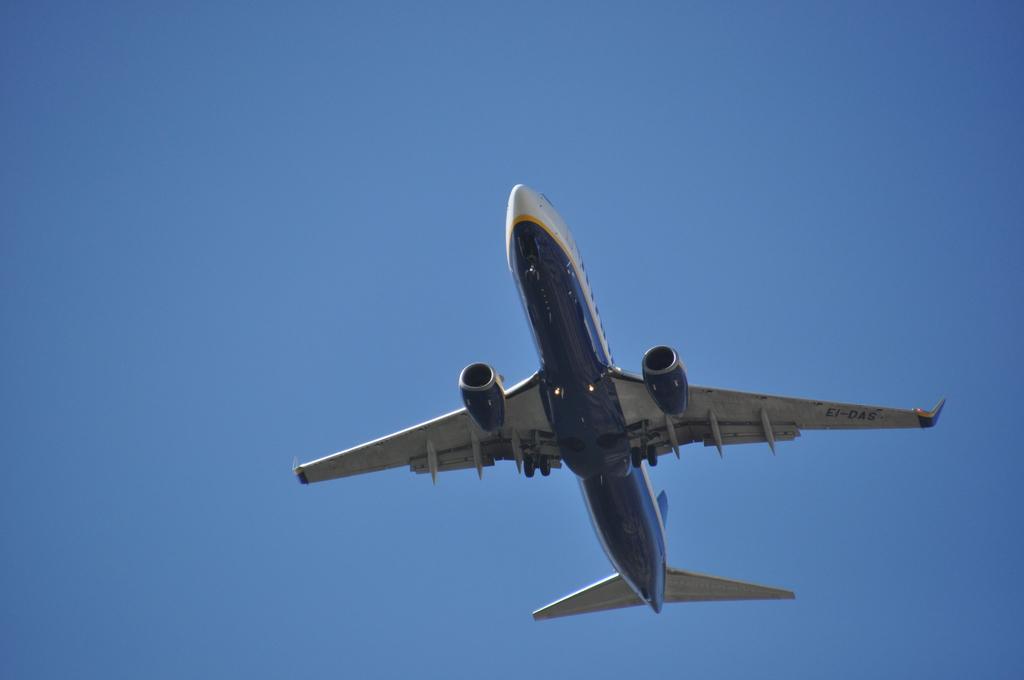How would you summarize this image in a sentence or two? In this picture, we see an airplane in white and blue color is flying in the sky. In the background, we see the sky, which is blue in color. 